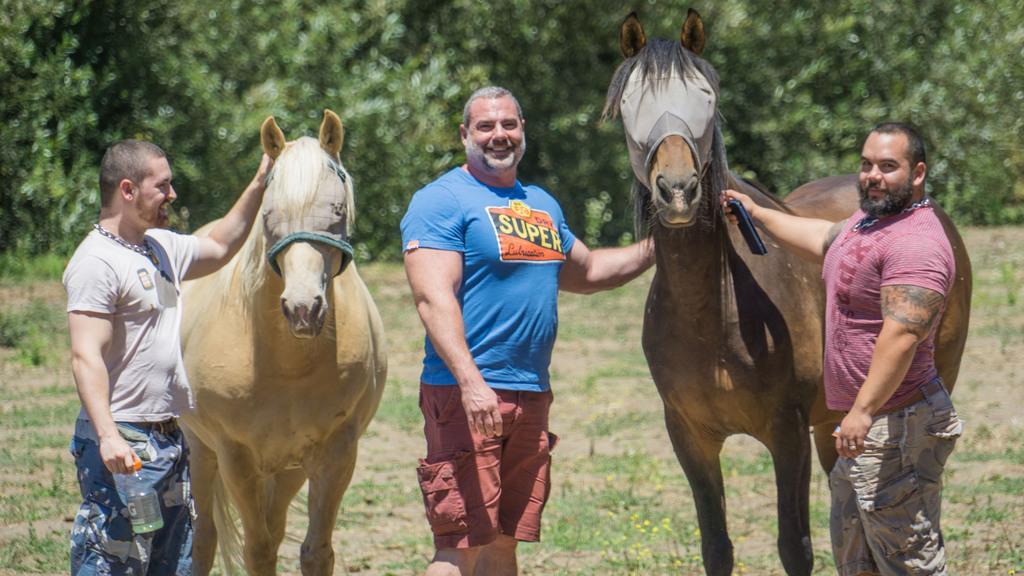Please provide a concise description of this image. We can see a man is standing in the middle and to either side of him there are two horses standing on the ground and on the left and right a man is holding a bottle and another man is holding an object in their hands receptively. In the background we can see trees and grass on the ground. 